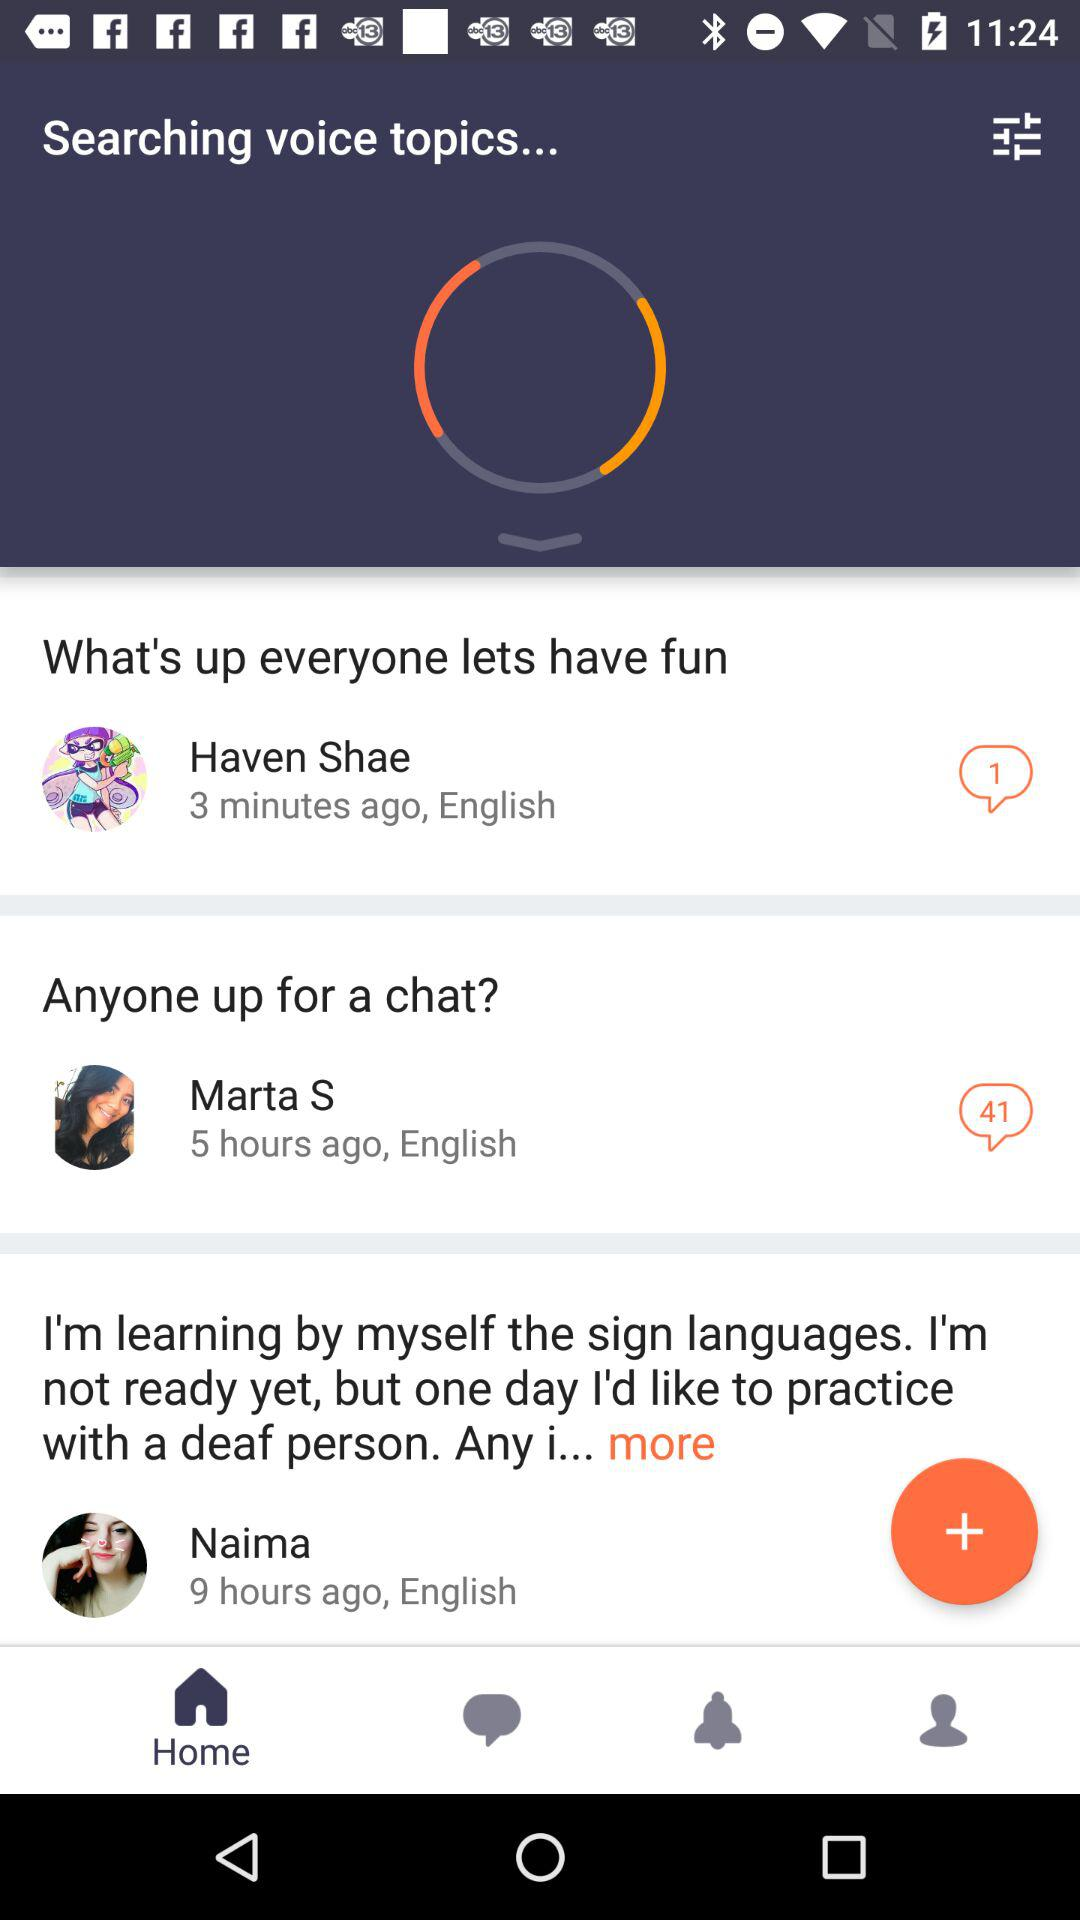When did Marta S comment? Marta S made a comment five hours ago. 